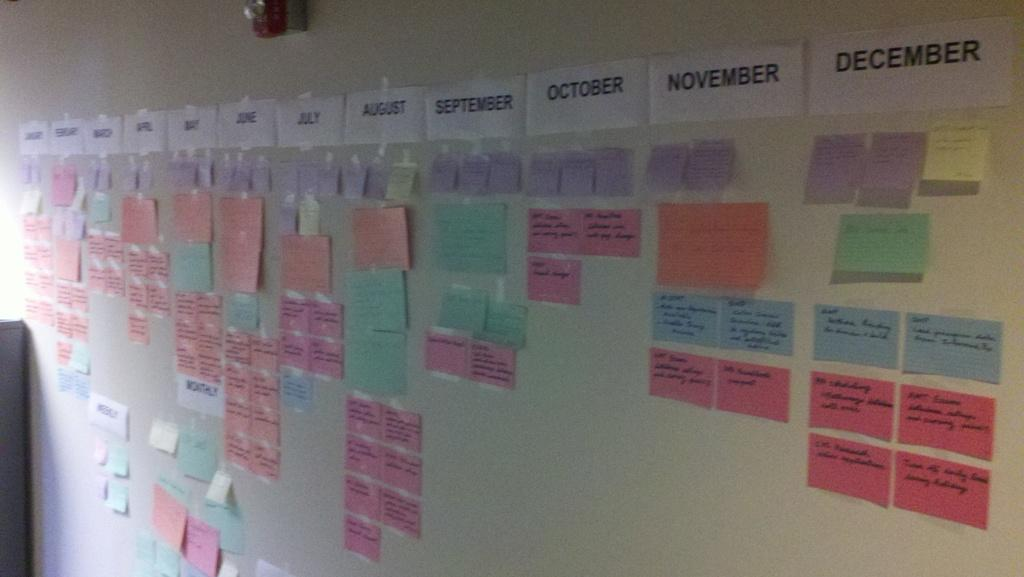<image>
Provide a brief description of the given image. the word November is on the white sign above the board 